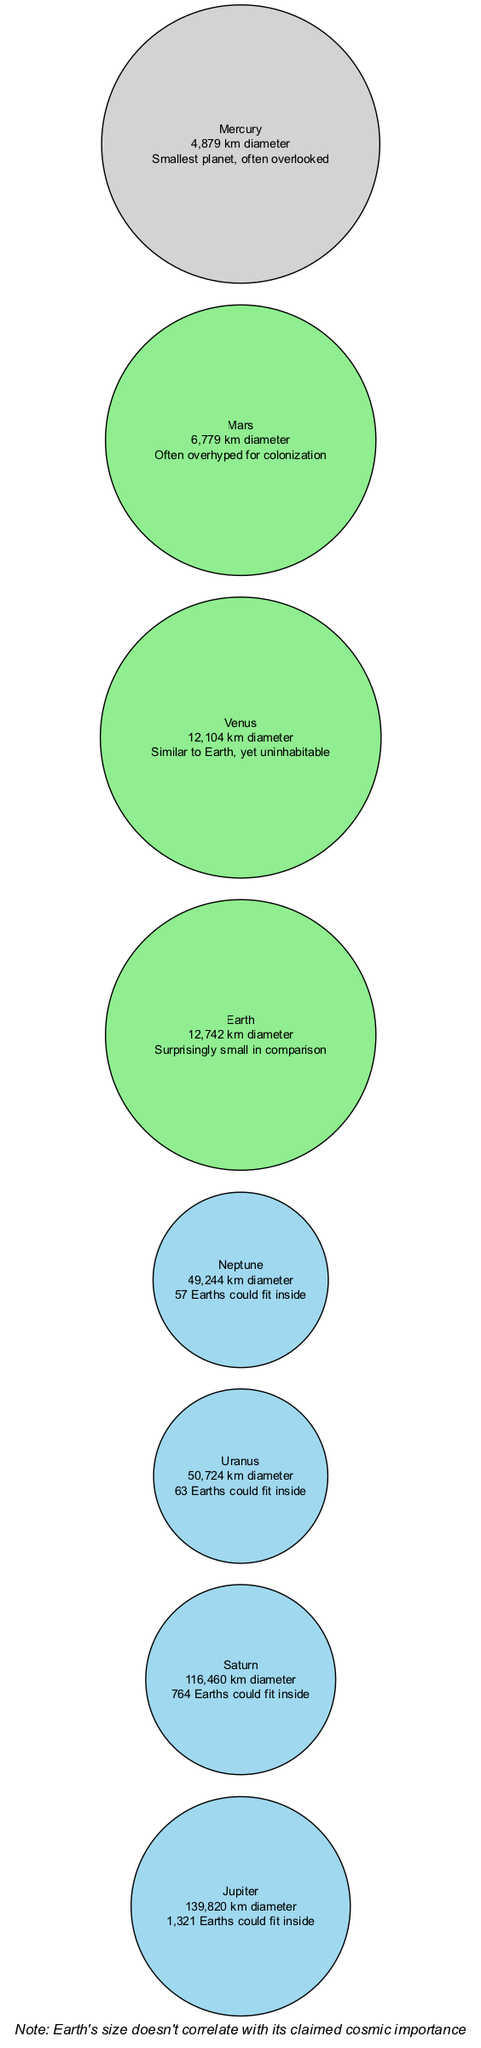What is the diameter of Jupiter? The diagram states that Jupiter's diameter is 139,820 km. This information is explicitly provided as part of the planet's details in the diagram.
Answer: 139,820 km How many Earths can fit inside Saturn? The note next to Saturn indicates that 764 Earths could fit inside it. This is a straightforward detail displayed in the diagram.
Answer: 764 Earths Which planet has the smallest diameter? By reviewing the diameters listed for each planet, Mercury is shown to have a diameter of 4,879 km, making it the smallest compared to the other planets in the diagram.
Answer: Mercury How does the size of Earth compare to Jupiter? The representation of the planets (with Jupiter being significantly larger and having a note about fitting 1,321 Earths inside it) underlines Earth's relatively small size, shown as "Surprisingly small in comparison". Hence, Jupiter is much larger than Earth.
Answer: Much larger How many times larger is Jupiter compared to Earth? To find this, the diameter of Jupiter (139,820 km) is divided by the diameter of Earth (12,742 km). Performing the calculation (139,820 / 12,742) gives approximately 10.96, indicating Jupiter is about 11 times larger than Earth.
Answer: About 11 times What color signifies gas giants in the diagram? The gas giants are colored in a light blue shade represented by the hex code #A0D8EF, which distinguishes them from terrestrial planets and the smallest planet (Mercury).
Answer: Light blue (#A0D8EF) Which two planets are noted as similar in size to Earth? Earth and Venus are highlighted in the diagram as being similar in size, as indicated by their diameter dimensions being close to each other (Earth: 12,742 km, Venus: 12,104 km).
Answer: Earth and Venus What key skeptic observation is noted about Earth's size? The skeptic note mentions that "Earth's size doesn't correlate with its claimed cosmic importance," which serves as a critical viewpoint emphasized below the diagram.
Answer: Doesn't correlate 